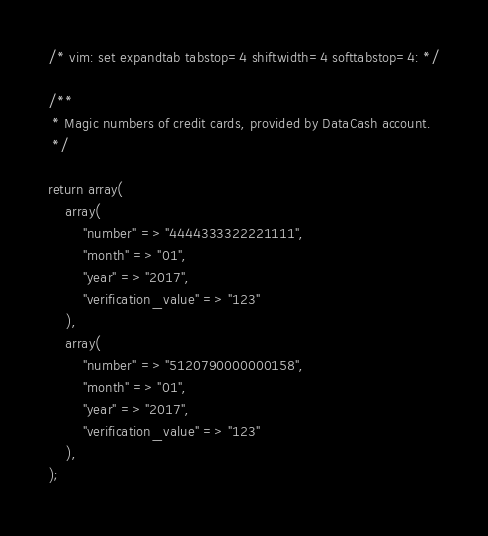<code> <loc_0><loc_0><loc_500><loc_500><_PHP_>
/* vim: set expandtab tabstop=4 shiftwidth=4 softtabstop=4: */

/**
 * Magic numbers of credit cards, provided by DataCash account.
 */

return array(
    array(
        "number" => "4444333322221111",
        "month" => "01",
        "year" => "2017",
        "verification_value" => "123"
    ),
    array(
        "number" => "5120790000000158",
        "month" => "01",
        "year" => "2017",
        "verification_value" => "123"
    ),
);
</code> 